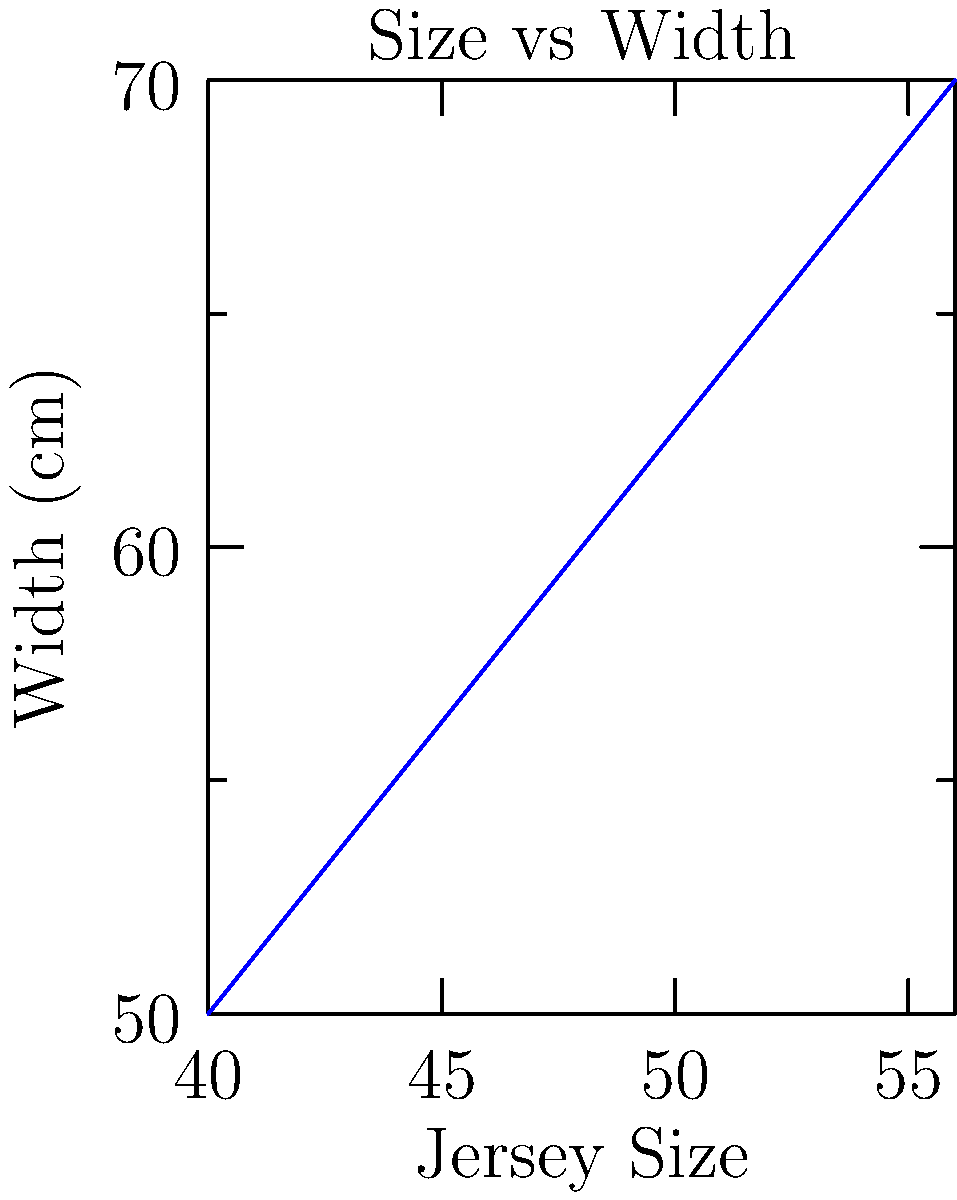You're designing a new uniform concept for a sports team and need to scale the design across different sizes. The graph shows the relationship between jersey size and width. If you've created the initial design for a size 48 jersey, what scale factor should you use to resize the design for a size 56 jersey to maintain proportions? To find the scale factor, we need to follow these steps:

1. Identify the widths for size 48 and size 56 jerseys from the graph:
   - Size 48 width: 60 cm
   - Size 56 width: 70 cm

2. Calculate the scale factor using the formula:
   $$ \text{Scale Factor} = \frac{\text{New Size}}{\text{Original Size}} $$

3. Plug in the values:
   $$ \text{Scale Factor} = \frac{70 \text{ cm}}{60 \text{ cm}} $$

4. Simplify the fraction:
   $$ \text{Scale Factor} = \frac{7}{6} \approx 1.1667 $$

Therefore, to resize the design from a size 48 to a size 56 jersey, you should use a scale factor of $\frac{7}{6}$ or approximately 1.1667.
Answer: $\frac{7}{6}$ or 1.1667 